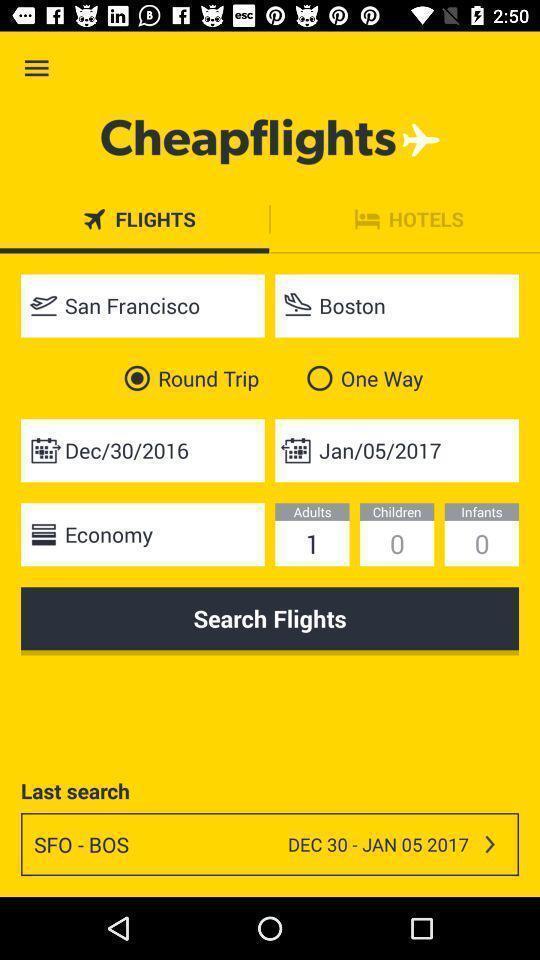What can you discern from this picture? Search page of flights booking app. 